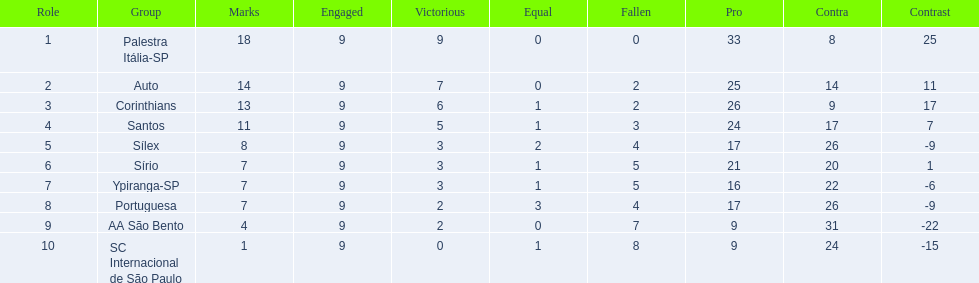What are all the teams? Palestra Itália-SP, Auto, Corinthians, Santos, Sílex, Sírio, Ypiranga-SP, Portuguesa, AA São Bento, SC Internacional de São Paulo. How many times did each team lose? 0, 2, 2, 3, 4, 5, 5, 4, 7, 8. And which team never lost? Palestra Itália-SP. 